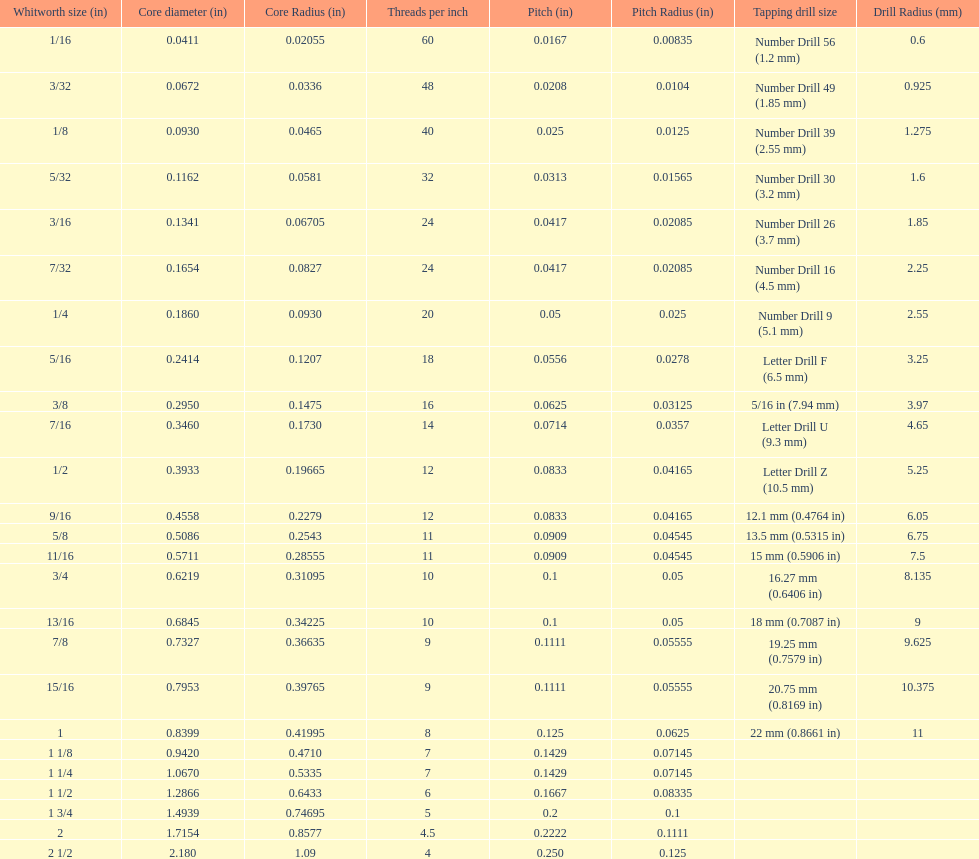What is the aggregate of the initial two core diameters? 0.1083. 